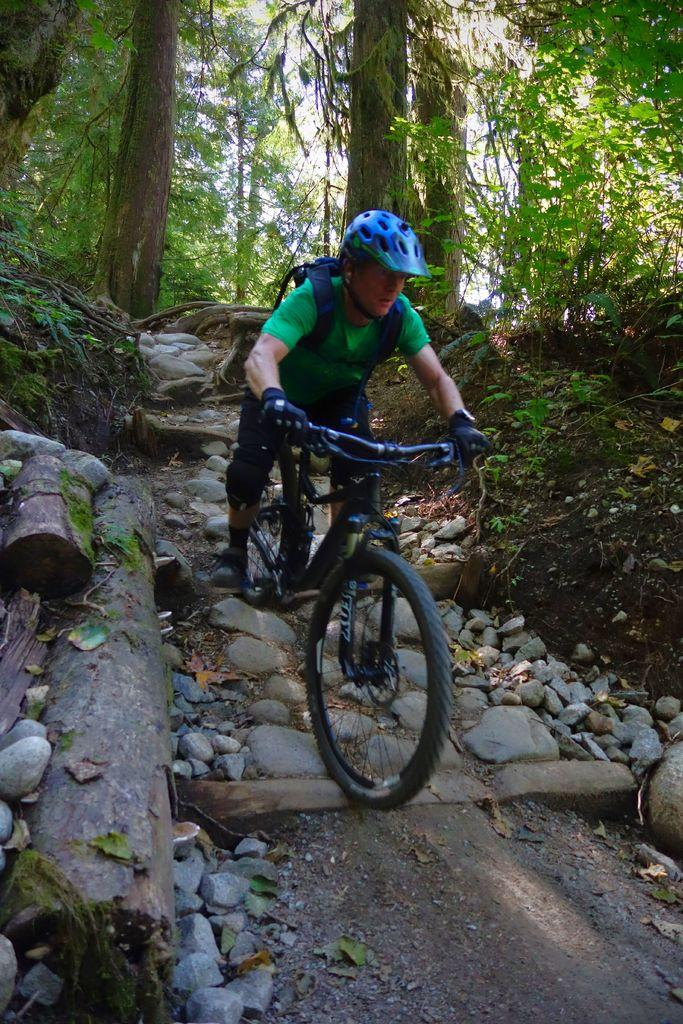What is the main subject of the image? There is a person in the image. What is the person doing in the image? The person is riding a bicycle. Where is the bicycle located? The bicycle is in the woods. What can be seen behind the person? There are trees behind the person. What degree does the person have in the image? There is no information about the person's degree in the image. Is there a volcano visible in the image? No, there is no volcano present in the image. 